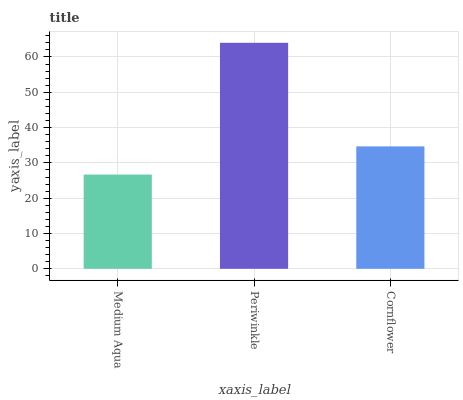Is Cornflower the minimum?
Answer yes or no. No. Is Cornflower the maximum?
Answer yes or no. No. Is Periwinkle greater than Cornflower?
Answer yes or no. Yes. Is Cornflower less than Periwinkle?
Answer yes or no. Yes. Is Cornflower greater than Periwinkle?
Answer yes or no. No. Is Periwinkle less than Cornflower?
Answer yes or no. No. Is Cornflower the high median?
Answer yes or no. Yes. Is Cornflower the low median?
Answer yes or no. Yes. Is Periwinkle the high median?
Answer yes or no. No. Is Medium Aqua the low median?
Answer yes or no. No. 